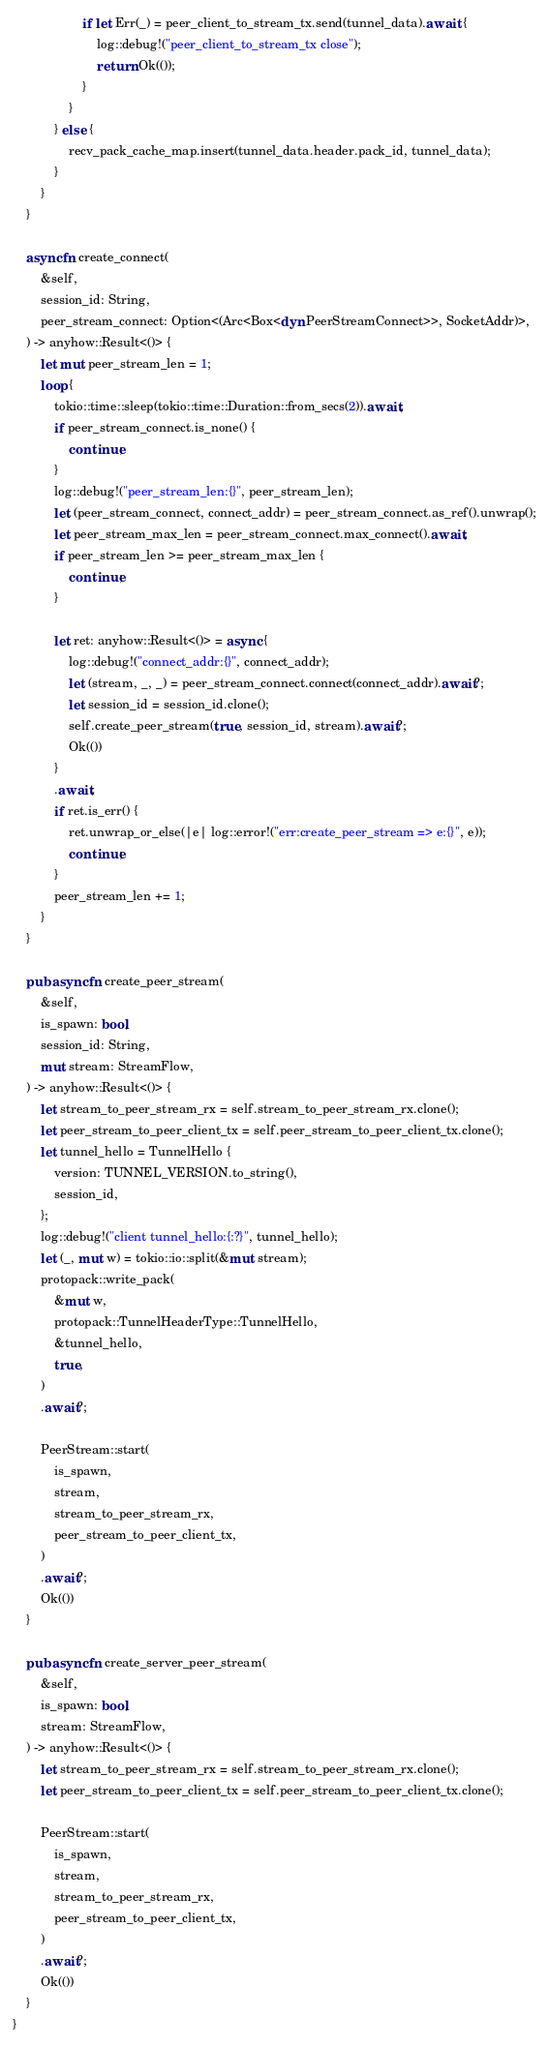<code> <loc_0><loc_0><loc_500><loc_500><_Rust_>                    if let Err(_) = peer_client_to_stream_tx.send(tunnel_data).await {
                        log::debug!("peer_client_to_stream_tx close");
                        return Ok(());
                    }
                }
            } else {
                recv_pack_cache_map.insert(tunnel_data.header.pack_id, tunnel_data);
            }
        }
    }

    async fn create_connect(
        &self,
        session_id: String,
        peer_stream_connect: Option<(Arc<Box<dyn PeerStreamConnect>>, SocketAddr)>,
    ) -> anyhow::Result<()> {
        let mut peer_stream_len = 1;
        loop {
            tokio::time::sleep(tokio::time::Duration::from_secs(2)).await;
            if peer_stream_connect.is_none() {
                continue;
            }
            log::debug!("peer_stream_len:{}", peer_stream_len);
            let (peer_stream_connect, connect_addr) = peer_stream_connect.as_ref().unwrap();
            let peer_stream_max_len = peer_stream_connect.max_connect().await;
            if peer_stream_len >= peer_stream_max_len {
                continue;
            }

            let ret: anyhow::Result<()> = async {
                log::debug!("connect_addr:{}", connect_addr);
                let (stream, _, _) = peer_stream_connect.connect(connect_addr).await?;
                let session_id = session_id.clone();
                self.create_peer_stream(true, session_id, stream).await?;
                Ok(())
            }
            .await;
            if ret.is_err() {
                ret.unwrap_or_else(|e| log::error!("err:create_peer_stream => e:{}", e));
                continue;
            }
            peer_stream_len += 1;
        }
    }

    pub async fn create_peer_stream(
        &self,
        is_spawn: bool,
        session_id: String,
        mut stream: StreamFlow,
    ) -> anyhow::Result<()> {
        let stream_to_peer_stream_rx = self.stream_to_peer_stream_rx.clone();
        let peer_stream_to_peer_client_tx = self.peer_stream_to_peer_client_tx.clone();
        let tunnel_hello = TunnelHello {
            version: TUNNEL_VERSION.to_string(),
            session_id,
        };
        log::debug!("client tunnel_hello:{:?}", tunnel_hello);
        let (_, mut w) = tokio::io::split(&mut stream);
        protopack::write_pack(
            &mut w,
            protopack::TunnelHeaderType::TunnelHello,
            &tunnel_hello,
            true,
        )
        .await?;

        PeerStream::start(
            is_spawn,
            stream,
            stream_to_peer_stream_rx,
            peer_stream_to_peer_client_tx,
        )
        .await?;
        Ok(())
    }

    pub async fn create_server_peer_stream(
        &self,
        is_spawn: bool,
        stream: StreamFlow,
    ) -> anyhow::Result<()> {
        let stream_to_peer_stream_rx = self.stream_to_peer_stream_rx.clone();
        let peer_stream_to_peer_client_tx = self.peer_stream_to_peer_client_tx.clone();

        PeerStream::start(
            is_spawn,
            stream,
            stream_to_peer_stream_rx,
            peer_stream_to_peer_client_tx,
        )
        .await?;
        Ok(())
    }
}
</code> 